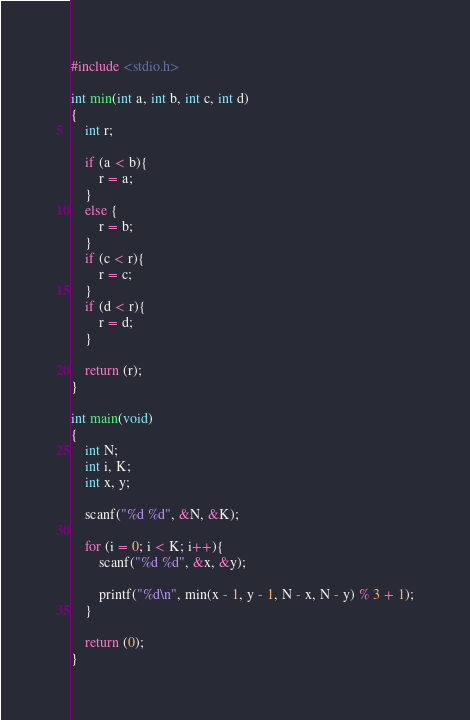Convert code to text. <code><loc_0><loc_0><loc_500><loc_500><_C_>#include <stdio.h>

int min(int a, int b, int c, int d)
{
	int r;
	
	if (a < b){
		r = a;
	}
	else {
		r = b;
	}
	if (c < r){
		r = c;
	}
	if (d < r){
		r = d;
	}
	
	return (r);
}

int main(void)
{
	int N;
	int i, K;
	int x, y;
	
	scanf("%d %d", &N, &K);
	
	for (i = 0; i < K; i++){
		scanf("%d %d", &x, &y);
		
		printf("%d\n", min(x - 1, y - 1, N - x, N - y) % 3 + 1);
	}
	
	return (0);
}</code> 